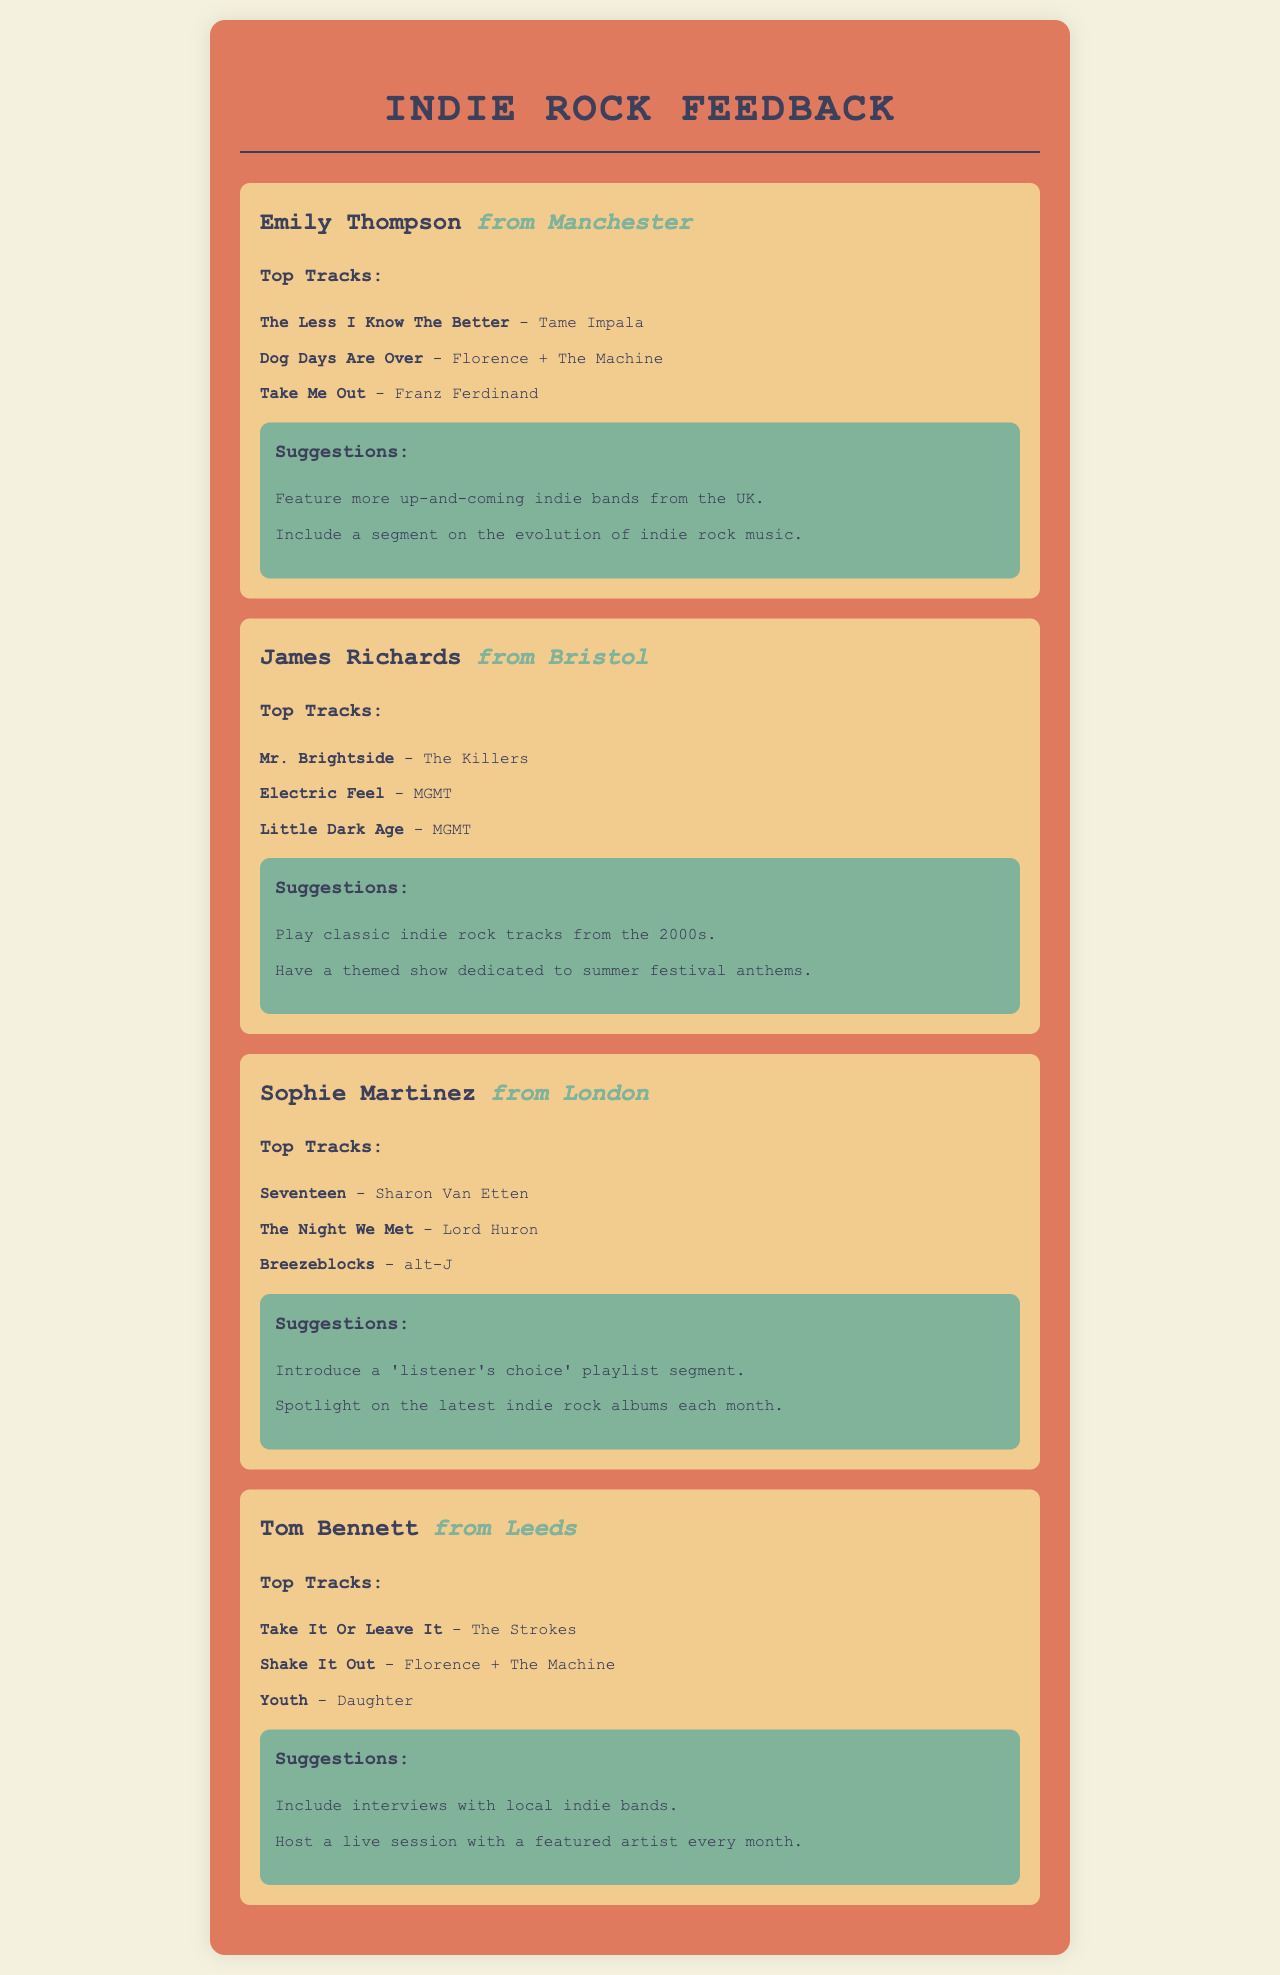What are Emily Thompson's top tracks? The document lists three top tracks from Emily Thompson, which are "The Less I Know The Better," "Dog Days Are Over," and "Take Me Out."
Answer: The Less I Know The Better, Dog Days Are Over, Take Me Out What is one suggestion from James Richards? The document provides two suggestions from James Richards, one of which is "Play classic indie rock tracks from the 2000s."
Answer: Play classic indie rock tracks from the 2000s Which city is Sophie Martinez from? The city mentioned for Sophie Martinez in the document is London.
Answer: London How many top tracks did Tom Bennett list? The document indicates that Tom Bennett listed three top tracks.
Answer: Three What color is the background of the feedback sections? The document describes the background color of the feedback sections as a light tan or beige.
Answer: Light tan What type of show does Tom Bennett suggest featuring? The document mentions that Tom Bennett suggests hosting a live session with a featured artist every month.
Answer: Live session with a featured artist every month Which band is featured in Sophie Martinez's top tracks? The document states that "Breezeblocks" by alt-J is one of Sophie Martinez's top tracks.
Answer: alt-J What is a suggestion made by Emily Thompson? One of the suggestions made by Emily Thompson is to "Feature more up-and-coming indie bands from the UK."
Answer: Feature more up-and-coming indie bands from the UK 